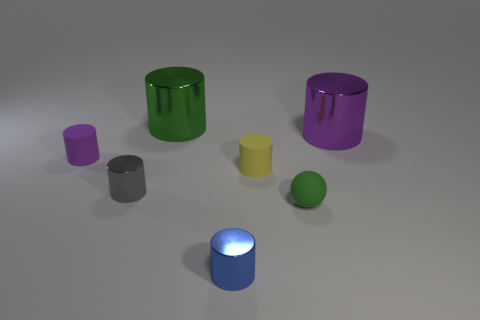Can you describe the arrangement of objects in this image? Certainly! The image displays a collection of geometric shapes positioned on a flat surface. There are two large cylinders, one green and one purple, positioned towards the back. In the foreground, there's a smaller purple cylinder, a matte yellow cylinder, and a grey cube, all of which are to the left of a green sphere. On the right, towards the front, is a small blue cylinder emanating light from the top, suggesting it could be a source of illumination or a representation of an LED light. 